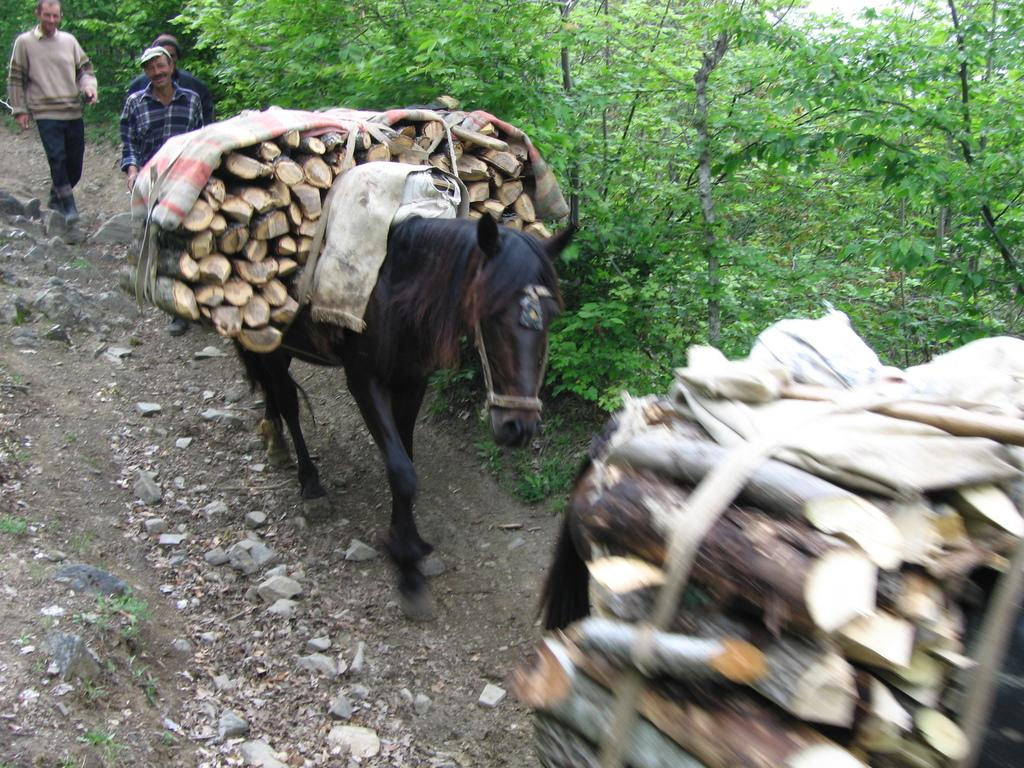What animal is the main subject of the image? There is a horse in the image. What is the horse carrying? The horse is carrying wooden pieces. Are there any people visible in the image? Yes, there are people walking in the image. What type of vegetation can be seen in the image? There are trees in the image. What type of lettuce is growing in the alley in the image? There is no lettuce or alley present in the image. Can you describe the bee's behavior in the image? There are no bees present in the image. 